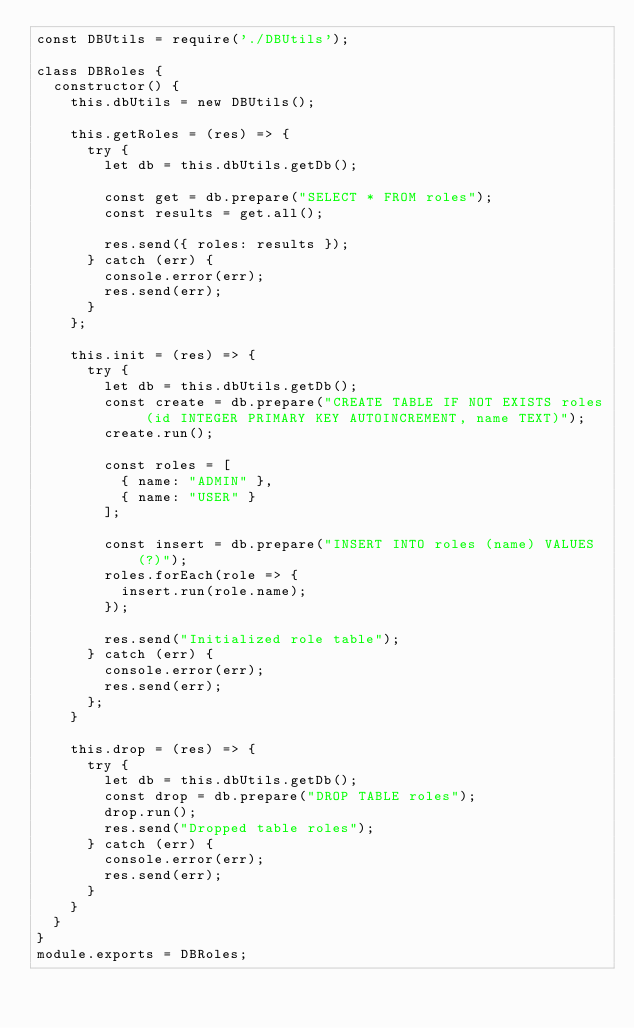Convert code to text. <code><loc_0><loc_0><loc_500><loc_500><_JavaScript_>const DBUtils = require('./DBUtils');

class DBRoles {
  constructor() {
    this.dbUtils = new DBUtils();

    this.getRoles = (res) => {
      try {
        let db = this.dbUtils.getDb();

        const get = db.prepare("SELECT * FROM roles");
        const results = get.all();

        res.send({ roles: results });
      } catch (err) {
        console.error(err);
        res.send(err);
      }
    };

    this.init = (res) => {
      try {
        let db = this.dbUtils.getDb();
        const create = db.prepare("CREATE TABLE IF NOT EXISTS roles (id INTEGER PRIMARY KEY AUTOINCREMENT, name TEXT)");
        create.run();

        const roles = [
          { name: "ADMIN" },
          { name: "USER" }
        ];

        const insert = db.prepare("INSERT INTO roles (name) VALUES (?)");
        roles.forEach(role => {
          insert.run(role.name);
        });
        
        res.send("Initialized role table");
      } catch (err) {
        console.error(err);
        res.send(err);
      };
    }

    this.drop = (res) => {
      try {
        let db = this.dbUtils.getDb();
        const drop = db.prepare("DROP TABLE roles");
        drop.run();
        res.send("Dropped table roles");
      } catch (err) {
        console.error(err);
        res.send(err);
      }
    }
  }
}
module.exports = DBRoles;</code> 